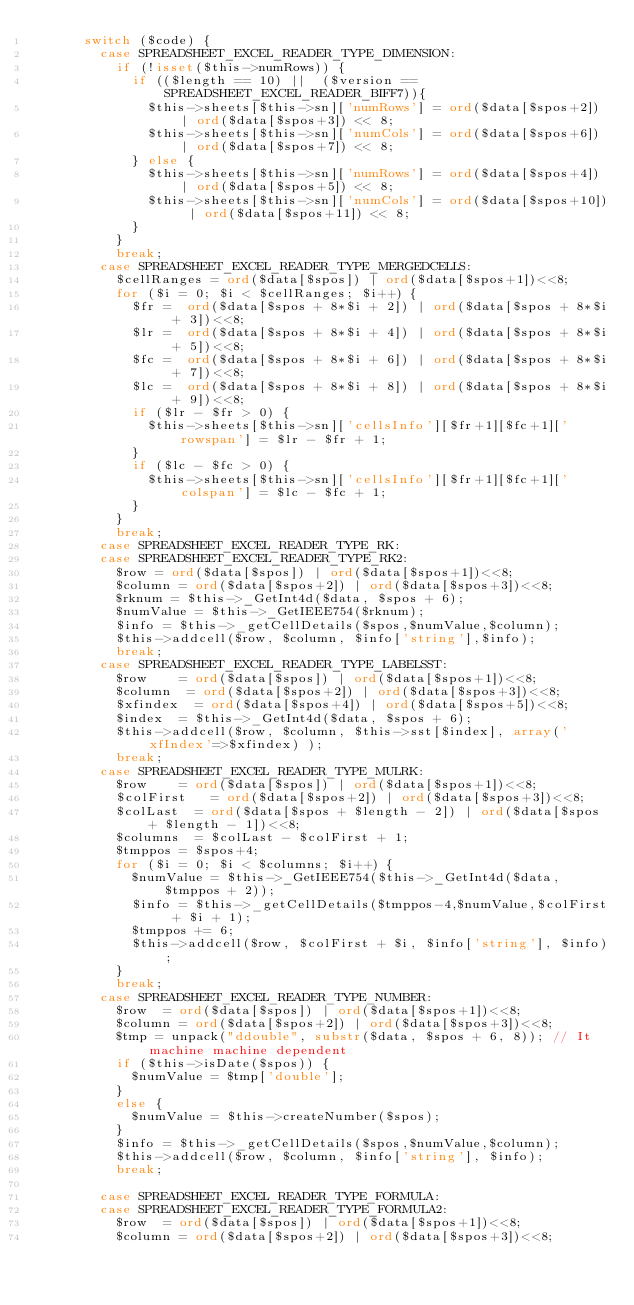Convert code to text. <code><loc_0><loc_0><loc_500><loc_500><_PHP_>			switch ($code) {
				case SPREADSHEET_EXCEL_READER_TYPE_DIMENSION:
					if (!isset($this->numRows)) {
						if (($length == 10) ||  ($version == SPREADSHEET_EXCEL_READER_BIFF7)){
							$this->sheets[$this->sn]['numRows'] = ord($data[$spos+2]) | ord($data[$spos+3]) << 8;
							$this->sheets[$this->sn]['numCols'] = ord($data[$spos+6]) | ord($data[$spos+7]) << 8;
						} else {
							$this->sheets[$this->sn]['numRows'] = ord($data[$spos+4]) | ord($data[$spos+5]) << 8;
							$this->sheets[$this->sn]['numCols'] = ord($data[$spos+10]) | ord($data[$spos+11]) << 8;
						}
					}
					break;
				case SPREADSHEET_EXCEL_READER_TYPE_MERGEDCELLS:
					$cellRanges = ord($data[$spos]) | ord($data[$spos+1])<<8;
					for ($i = 0; $i < $cellRanges; $i++) {
						$fr =  ord($data[$spos + 8*$i + 2]) | ord($data[$spos + 8*$i + 3])<<8;
						$lr =  ord($data[$spos + 8*$i + 4]) | ord($data[$spos + 8*$i + 5])<<8;
						$fc =  ord($data[$spos + 8*$i + 6]) | ord($data[$spos + 8*$i + 7])<<8;
						$lc =  ord($data[$spos + 8*$i + 8]) | ord($data[$spos + 8*$i + 9])<<8;
						if ($lr - $fr > 0) {
							$this->sheets[$this->sn]['cellsInfo'][$fr+1][$fc+1]['rowspan'] = $lr - $fr + 1;
						}
						if ($lc - $fc > 0) {
							$this->sheets[$this->sn]['cellsInfo'][$fr+1][$fc+1]['colspan'] = $lc - $fc + 1;
						}
					}
					break;
				case SPREADSHEET_EXCEL_READER_TYPE_RK:
				case SPREADSHEET_EXCEL_READER_TYPE_RK2:
					$row = ord($data[$spos]) | ord($data[$spos+1])<<8;
					$column = ord($data[$spos+2]) | ord($data[$spos+3])<<8;
					$rknum = $this->_GetInt4d($data, $spos + 6);
					$numValue = $this->_GetIEEE754($rknum);
					$info = $this->_getCellDetails($spos,$numValue,$column);
					$this->addcell($row, $column, $info['string'],$info);
					break;
				case SPREADSHEET_EXCEL_READER_TYPE_LABELSST:
					$row		= ord($data[$spos]) | ord($data[$spos+1])<<8;
					$column	 = ord($data[$spos+2]) | ord($data[$spos+3])<<8;
					$xfindex	= ord($data[$spos+4]) | ord($data[$spos+5])<<8;
					$index  = $this->_GetInt4d($data, $spos + 6);
					$this->addcell($row, $column, $this->sst[$index], array('xfIndex'=>$xfindex) );
					break;
				case SPREADSHEET_EXCEL_READER_TYPE_MULRK:
					$row		= ord($data[$spos]) | ord($data[$spos+1])<<8;
					$colFirst   = ord($data[$spos+2]) | ord($data[$spos+3])<<8;
					$colLast	= ord($data[$spos + $length - 2]) | ord($data[$spos + $length - 1])<<8;
					$columns	= $colLast - $colFirst + 1;
					$tmppos = $spos+4;
					for ($i = 0; $i < $columns; $i++) {
						$numValue = $this->_GetIEEE754($this->_GetInt4d($data, $tmppos + 2));
						$info = $this->_getCellDetails($tmppos-4,$numValue,$colFirst + $i + 1);
						$tmppos += 6;
						$this->addcell($row, $colFirst + $i, $info['string'], $info);
					}
					break;
				case SPREADSHEET_EXCEL_READER_TYPE_NUMBER:
					$row	= ord($data[$spos]) | ord($data[$spos+1])<<8;
					$column = ord($data[$spos+2]) | ord($data[$spos+3])<<8;
					$tmp = unpack("ddouble", substr($data, $spos + 6, 8)); // It machine machine dependent
					if ($this->isDate($spos)) {
						$numValue = $tmp['double'];
					}
					else {
						$numValue = $this->createNumber($spos);
					}
					$info = $this->_getCellDetails($spos,$numValue,$column);
					$this->addcell($row, $column, $info['string'], $info);
					break;

				case SPREADSHEET_EXCEL_READER_TYPE_FORMULA:
				case SPREADSHEET_EXCEL_READER_TYPE_FORMULA2:
					$row	= ord($data[$spos]) | ord($data[$spos+1])<<8;
					$column = ord($data[$spos+2]) | ord($data[$spos+3])<<8;</code> 